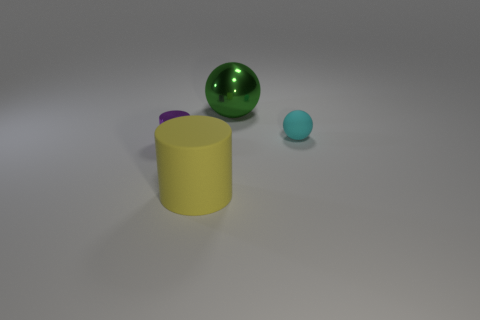How many yellow cylinders have the same size as the green thing?
Your response must be concise. 1. There is another object that is made of the same material as the small purple thing; what is its shape?
Provide a succinct answer. Sphere. What is the green ball made of?
Ensure brevity in your answer.  Metal. How many things are green metallic balls or tiny matte spheres?
Ensure brevity in your answer.  2. How big is the shiny thing that is on the right side of the yellow matte cylinder?
Your response must be concise. Large. How many other things are made of the same material as the tiny cyan thing?
Your answer should be compact. 1. There is a sphere that is behind the matte ball; are there any green things to the left of it?
Provide a short and direct response. No. What is the color of the other object that is the same shape as the cyan thing?
Your answer should be very brief. Green. The cyan matte thing has what size?
Provide a short and direct response. Small. Are there fewer big spheres behind the shiny cylinder than big cylinders?
Your answer should be very brief. No. 